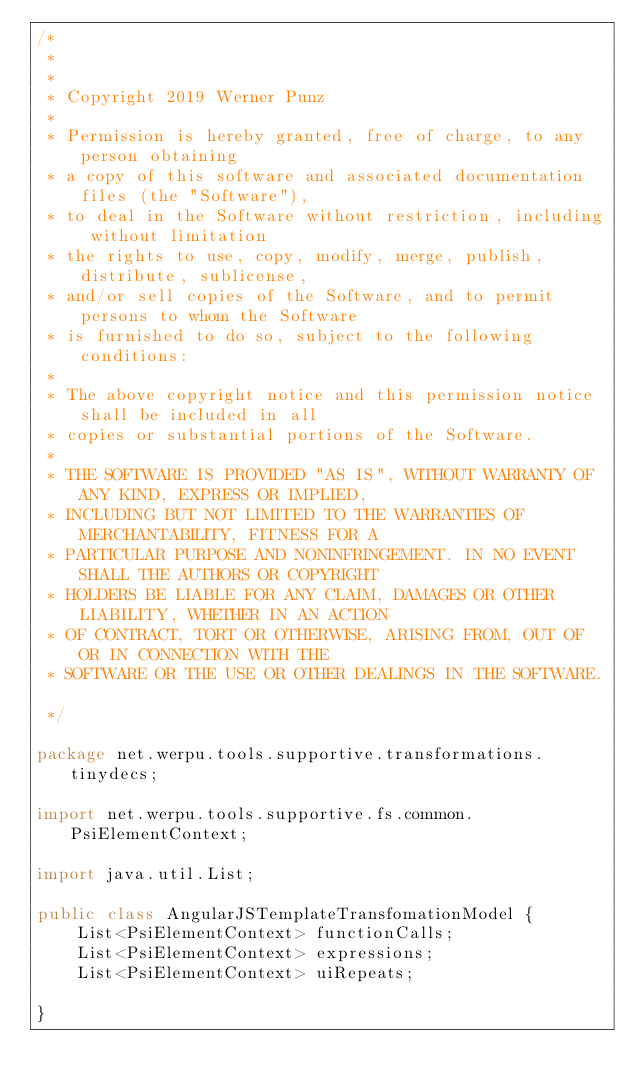<code> <loc_0><loc_0><loc_500><loc_500><_Java_>/*
 *
 *
 * Copyright 2019 Werner Punz
 *
 * Permission is hereby granted, free of charge, to any person obtaining
 * a copy of this software and associated documentation files (the "Software"),
 * to deal in the Software without restriction, including without limitation
 * the rights to use, copy, modify, merge, publish, distribute, sublicense,
 * and/or sell copies of the Software, and to permit persons to whom the Software
 * is furnished to do so, subject to the following conditions:
 *
 * The above copyright notice and this permission notice shall be included in all
 * copies or substantial portions of the Software.
 *
 * THE SOFTWARE IS PROVIDED "AS IS", WITHOUT WARRANTY OF ANY KIND, EXPRESS OR IMPLIED,
 * INCLUDING BUT NOT LIMITED TO THE WARRANTIES OF MERCHANTABILITY, FITNESS FOR A
 * PARTICULAR PURPOSE AND NONINFRINGEMENT. IN NO EVENT SHALL THE AUTHORS OR COPYRIGHT
 * HOLDERS BE LIABLE FOR ANY CLAIM, DAMAGES OR OTHER LIABILITY, WHETHER IN AN ACTION
 * OF CONTRACT, TORT OR OTHERWISE, ARISING FROM, OUT OF OR IN CONNECTION WITH THE
 * SOFTWARE OR THE USE OR OTHER DEALINGS IN THE SOFTWARE.

 */

package net.werpu.tools.supportive.transformations.tinydecs;

import net.werpu.tools.supportive.fs.common.PsiElementContext;

import java.util.List;

public class AngularJSTemplateTransfomationModel {
    List<PsiElementContext> functionCalls;
    List<PsiElementContext> expressions;
    List<PsiElementContext> uiRepeats;

}
</code> 